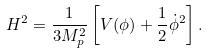Convert formula to latex. <formula><loc_0><loc_0><loc_500><loc_500>H ^ { 2 } = \frac { 1 } { 3 M _ { p } ^ { 2 } } \left [ V ( \phi ) + \frac { 1 } { 2 } \dot { \phi } ^ { 2 } \right ] .</formula> 